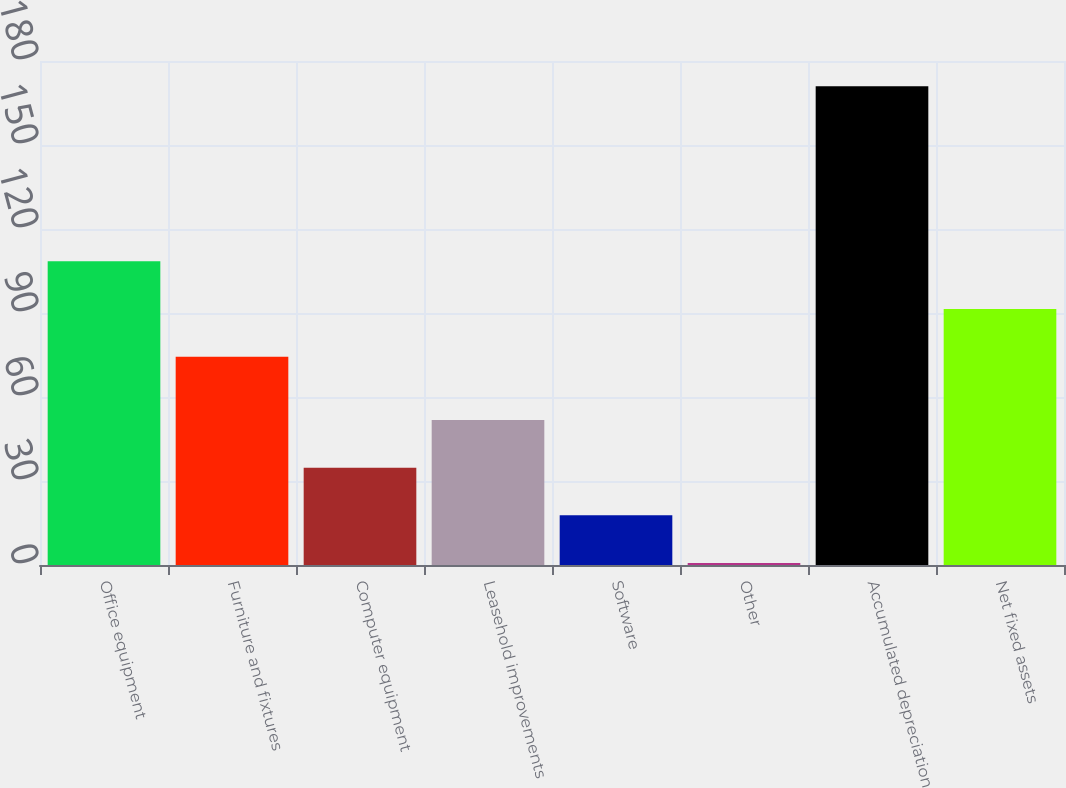Convert chart. <chart><loc_0><loc_0><loc_500><loc_500><bar_chart><fcel>Office equipment<fcel>Furniture and fixtures<fcel>Computer equipment<fcel>Leasehold improvements<fcel>Software<fcel>Other<fcel>Accumulated depreciation<fcel>Net fixed assets<nl><fcel>108.46<fcel>74.4<fcel>34.76<fcel>51.79<fcel>17.73<fcel>0.7<fcel>171<fcel>91.43<nl></chart> 